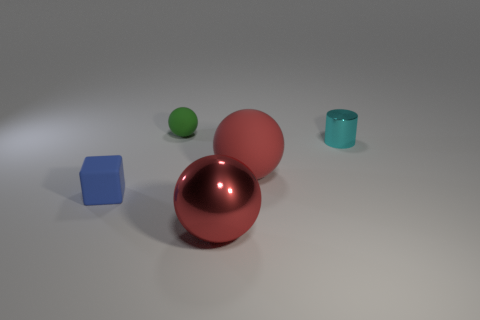Which object appears closest to the viewer? The object closest to the viewer is the larger red or maroon sphere situated at the center of the composition. Does it look like one of the objects might be able to contain something? Yes, the teal cylinder has an open top and resembles a cup, making it suitable for containing liquids or small objects. 